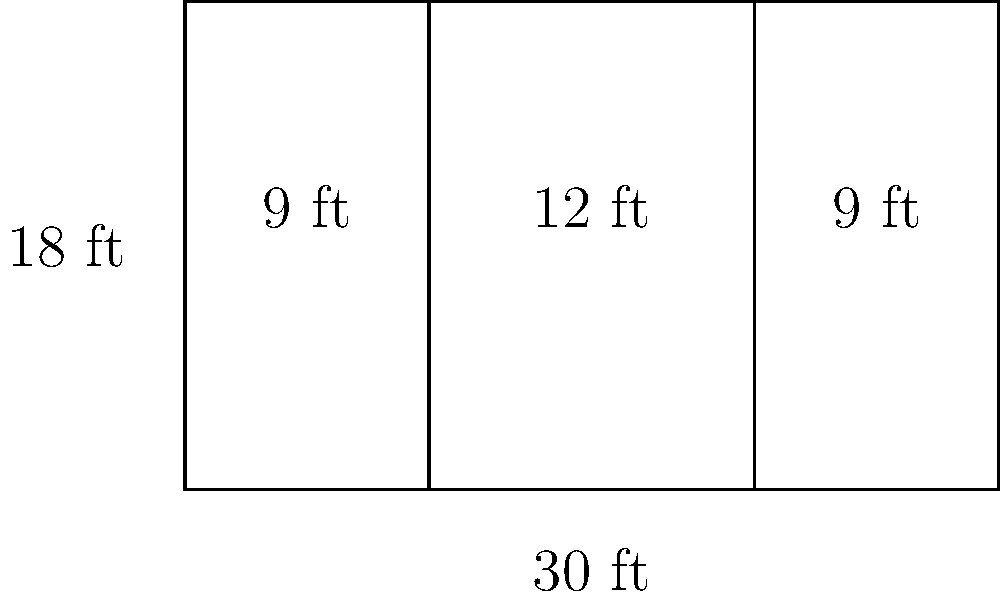In your insurance agency, you're redesigning the office space with rectangular cubicles. The office floor is rectangular, measuring 30 feet in length and 18 feet in width. You've divided it into three sections as shown in the diagram. What is the total area of all the cubicles in square feet? Let's approach this step-by-step:

1) First, we need to calculate the area of each section:

   Section 1 (left): 
   Length = 9 ft, Width = 18 ft
   Area = $9 \times 18 = 162$ sq ft

   Section 2 (middle):
   Length = 12 ft, Width = 18 ft
   Area = $12 \times 18 = 216$ sq ft

   Section 3 (right):
   Length = 9 ft, Width = 18 ft
   Area = $9 \times 18 = 162$ sq ft

2) Now, we sum up the areas of all sections:

   Total Area = Area of Section 1 + Area of Section 2 + Area of Section 3
               = $162 + 216 + 162$
               = $540$ sq ft

3) We can verify this by calculating the total area of the office:
   
   Total Office Area = Length × Width = $30 \times 18 = 540$ sq ft

This confirms our calculation is correct.
Answer: 540 sq ft 